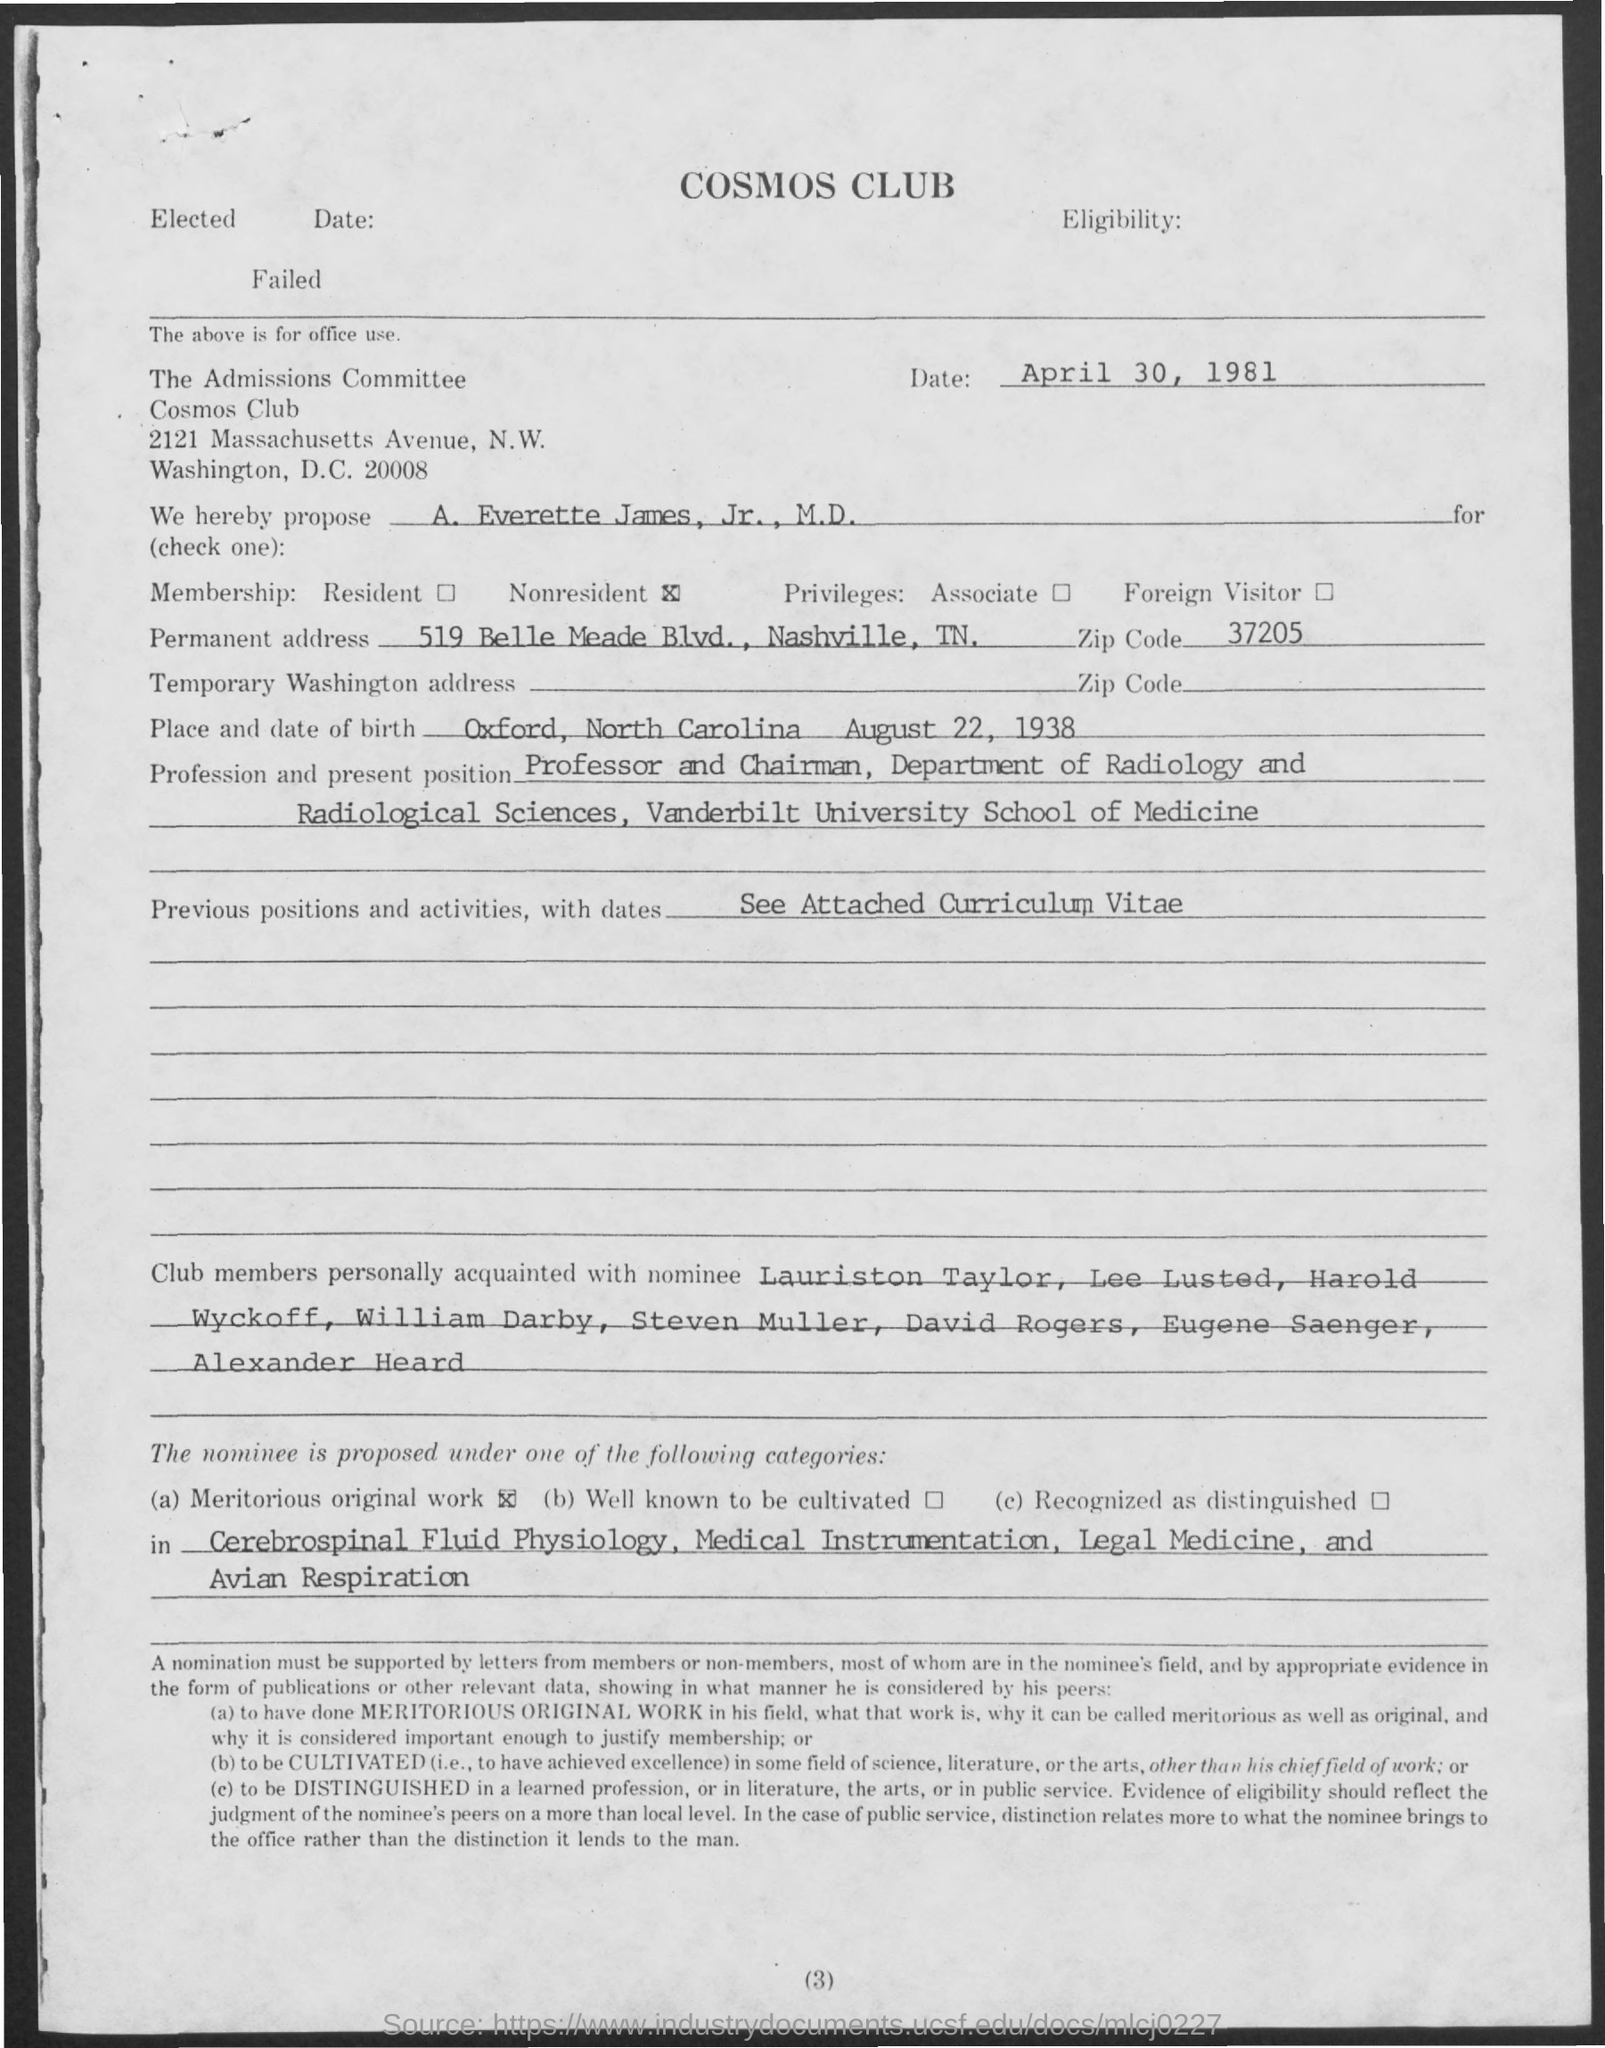Give some essential details in this illustration. The permanent address is located at 519 Belle Meade Boulevard in Nashville, Tennessee. August 22, 1938 is the date of birth. The place of birth is Oxford, North Carolina. The title of the document is Cosmos Club. 